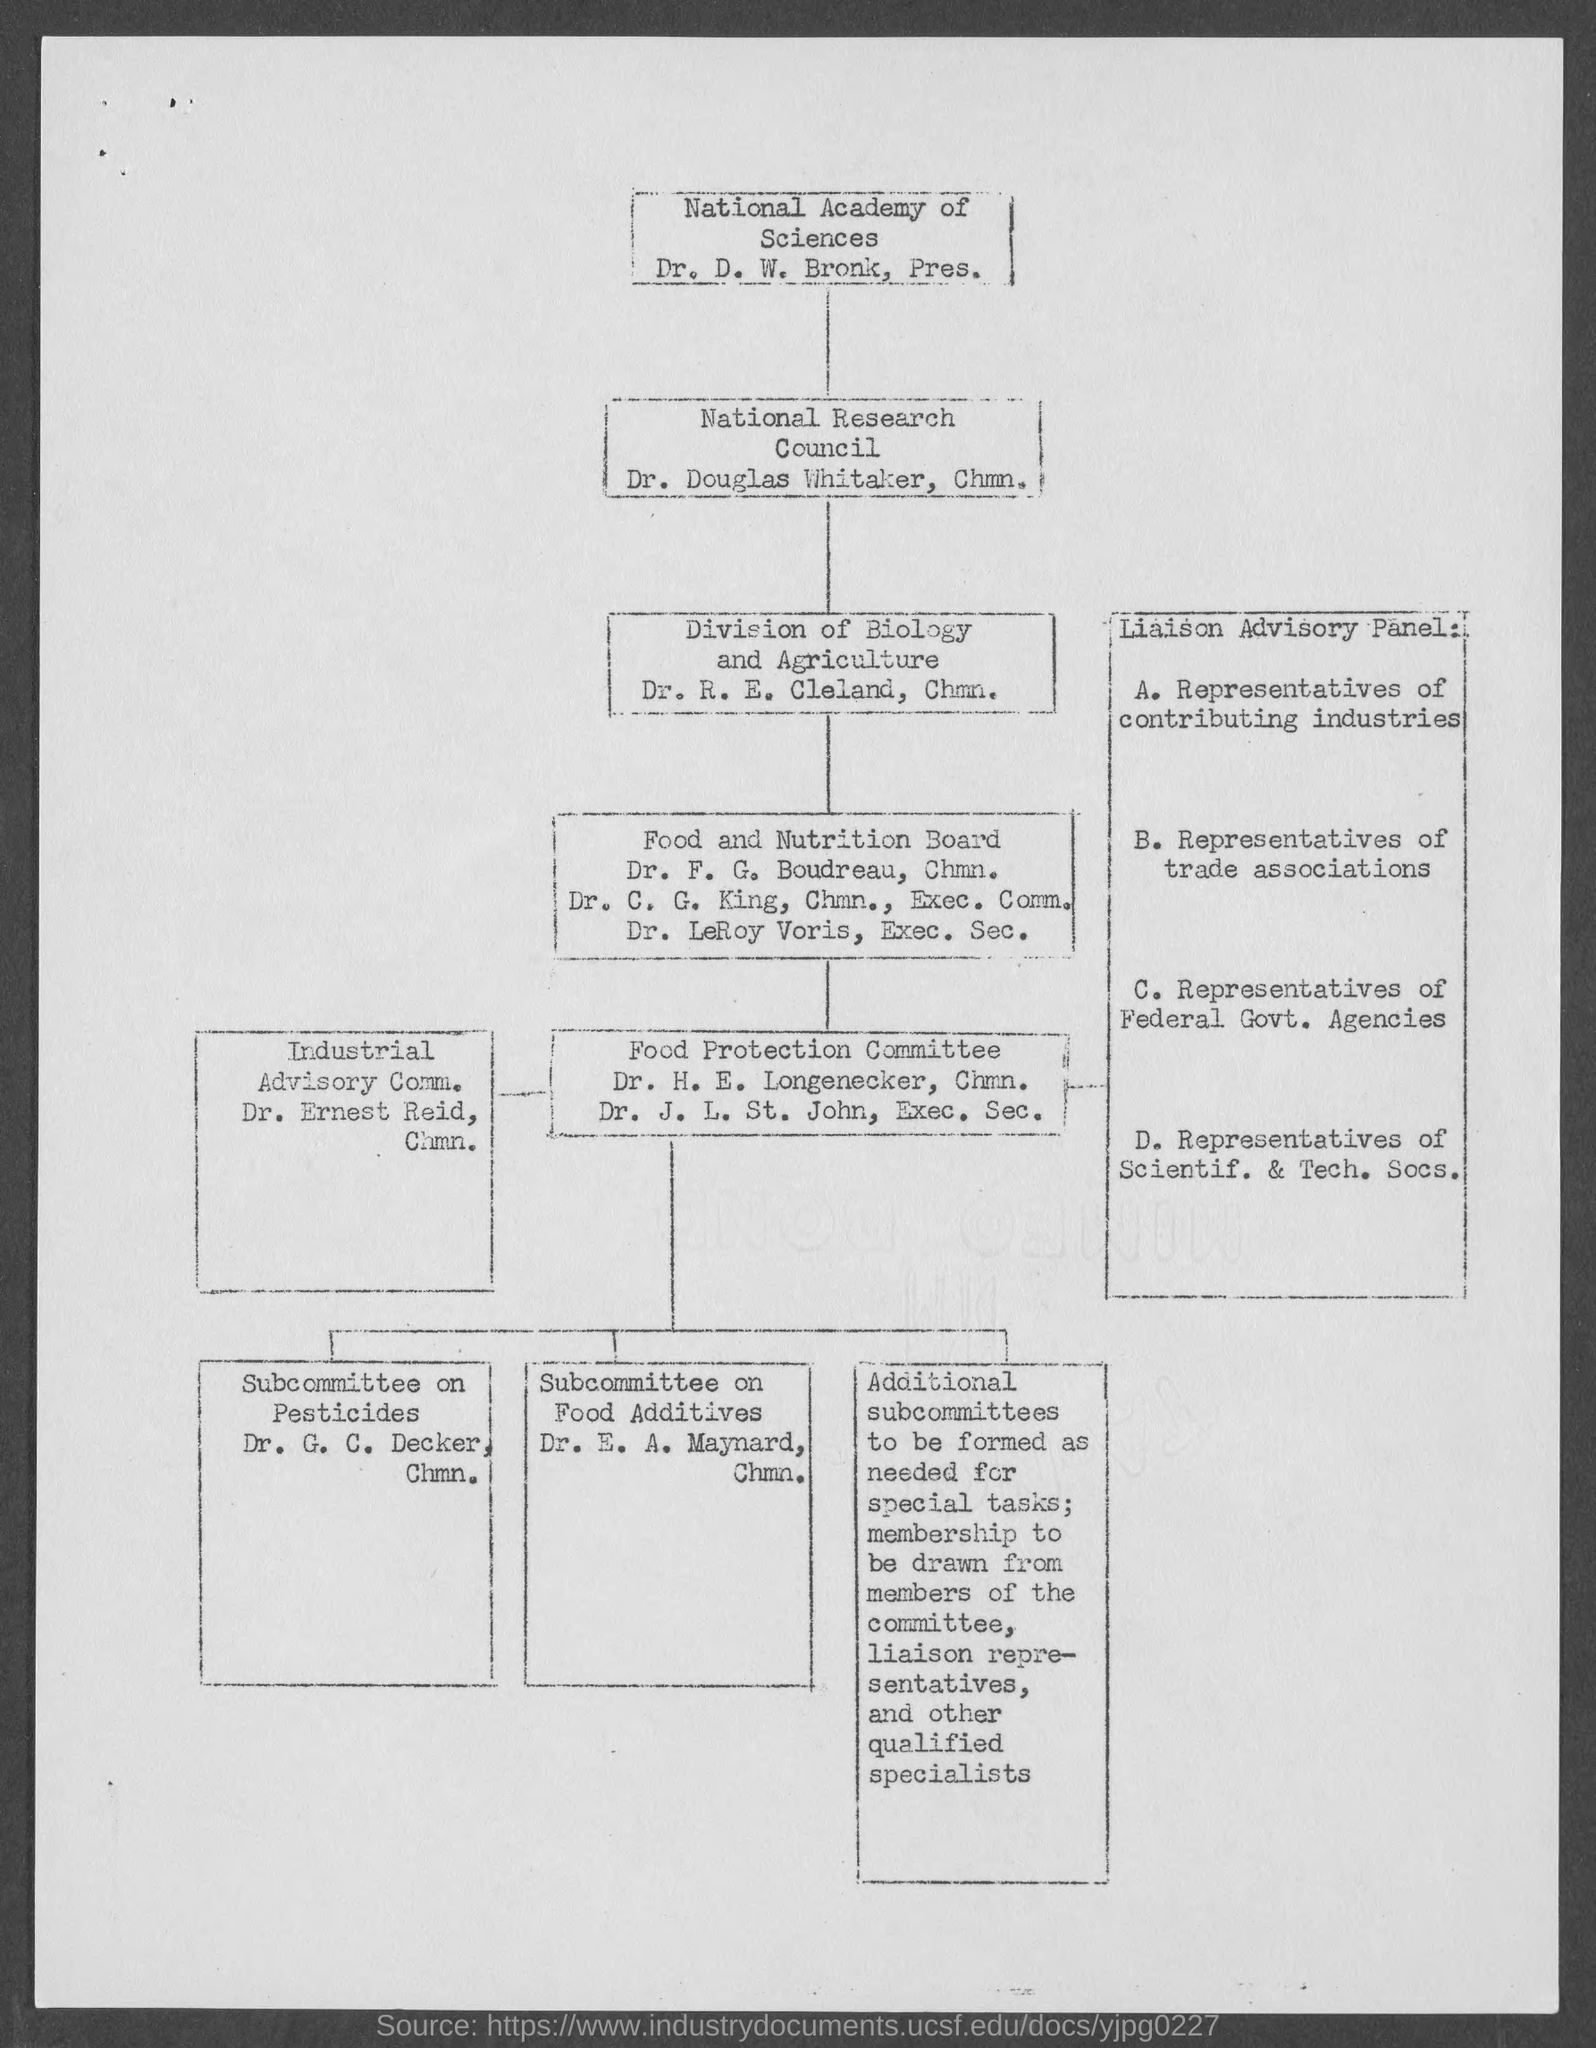What is the position of dr. d.w. bronk?
Your answer should be compact. Pres. What is the position of dr. douglas whitaker ?
Your answer should be very brief. Chmn. What is the position of dr. r.e. cleland ?
Offer a terse response. Chmn. What is the position of dr. ernest reid ?
Your response must be concise. Chmn. What is the position of dr. g. c. decker ?
Your response must be concise. Chmn. What is the position of dr. e. a. maynard ?
Ensure brevity in your answer.  Chmn. What is the position of dr.  f. g. boudreau?
Ensure brevity in your answer.  Chmn. What is the position of dr. leroy voris ?
Your answer should be compact. Exec. Sec. What is the position of dr. h.e. longenecker ?
Ensure brevity in your answer.  Chmn. What is the position of dr. j. l. st. john?
Your answer should be compact. Exec. sec. 